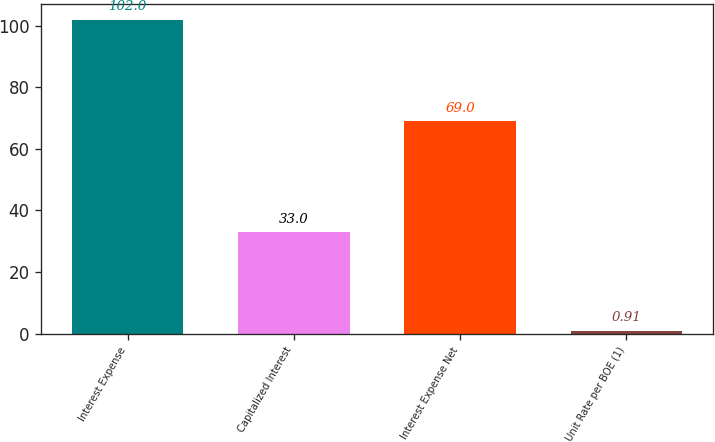<chart> <loc_0><loc_0><loc_500><loc_500><bar_chart><fcel>Interest Expense<fcel>Capitalized Interest<fcel>Interest Expense Net<fcel>Unit Rate per BOE (1)<nl><fcel>102<fcel>33<fcel>69<fcel>0.91<nl></chart> 